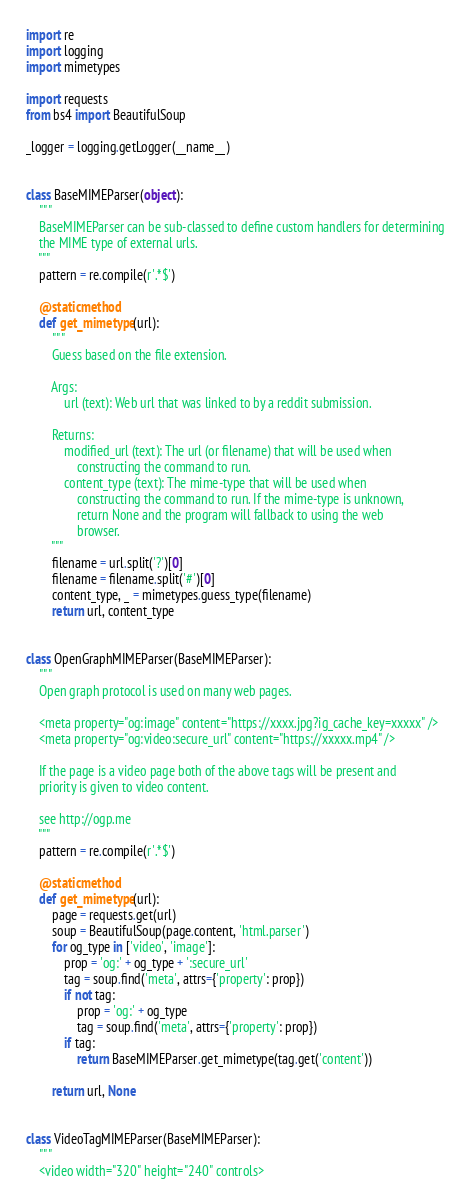Convert code to text. <code><loc_0><loc_0><loc_500><loc_500><_Python_>import re
import logging
import mimetypes

import requests
from bs4 import BeautifulSoup

_logger = logging.getLogger(__name__)


class BaseMIMEParser(object):
    """
    BaseMIMEParser can be sub-classed to define custom handlers for determining
    the MIME type of external urls.
    """
    pattern = re.compile(r'.*$')

    @staticmethod
    def get_mimetype(url):
        """
        Guess based on the file extension.

        Args:
            url (text): Web url that was linked to by a reddit submission.

        Returns:
            modified_url (text): The url (or filename) that will be used when
                constructing the command to run.
            content_type (text): The mime-type that will be used when
                constructing the command to run. If the mime-type is unknown,
                return None and the program will fallback to using the web
                browser.
        """
        filename = url.split('?')[0]
        filename = filename.split('#')[0]
        content_type, _ = mimetypes.guess_type(filename)
        return url, content_type


class OpenGraphMIMEParser(BaseMIMEParser):
    """
    Open graph protocol is used on many web pages.

    <meta property="og:image" content="https://xxxx.jpg?ig_cache_key=xxxxx" />
    <meta property="og:video:secure_url" content="https://xxxxx.mp4" />

    If the page is a video page both of the above tags will be present and
    priority is given to video content.

    see http://ogp.me
    """
    pattern = re.compile(r'.*$')

    @staticmethod
    def get_mimetype(url):
        page = requests.get(url)
        soup = BeautifulSoup(page.content, 'html.parser')
        for og_type in ['video', 'image']:
            prop = 'og:' + og_type + ':secure_url'
            tag = soup.find('meta', attrs={'property': prop})
            if not tag:
                prop = 'og:' + og_type
                tag = soup.find('meta', attrs={'property': prop})
            if tag:
                return BaseMIMEParser.get_mimetype(tag.get('content'))

        return url, None


class VideoTagMIMEParser(BaseMIMEParser):
    """
    <video width="320" height="240" controls></code> 